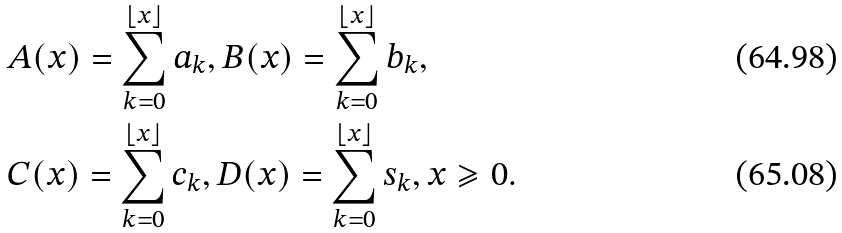Convert formula to latex. <formula><loc_0><loc_0><loc_500><loc_500>& A ( x ) = \sum _ { k = 0 } ^ { \lfloor x \rfloor } a _ { k } , B ( x ) = \sum _ { k = 0 } ^ { \lfloor x \rfloor } b _ { k } , \\ & C ( x ) = \sum _ { k = 0 } ^ { \lfloor x \rfloor } c _ { k } , D ( x ) = \sum _ { k = 0 } ^ { \lfloor x \rfloor } s _ { k } , x \geqslant 0 .</formula> 